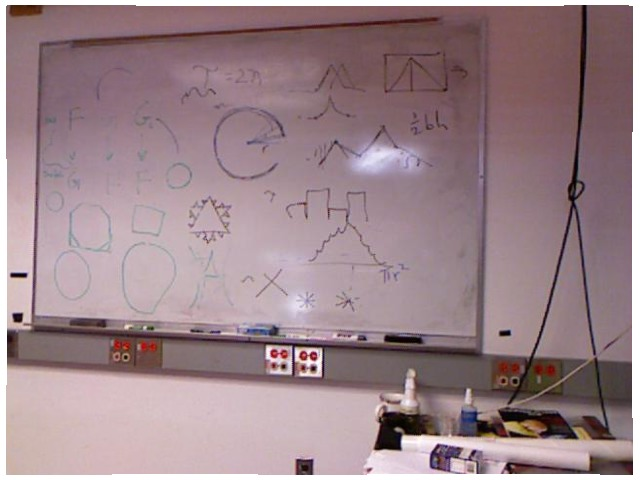<image>
Can you confirm if the drawing is on the whiteboard? Yes. Looking at the image, I can see the drawing is positioned on top of the whiteboard, with the whiteboard providing support. Is there a wires on the wall? No. The wires is not positioned on the wall. They may be near each other, but the wires is not supported by or resting on top of the wall. 